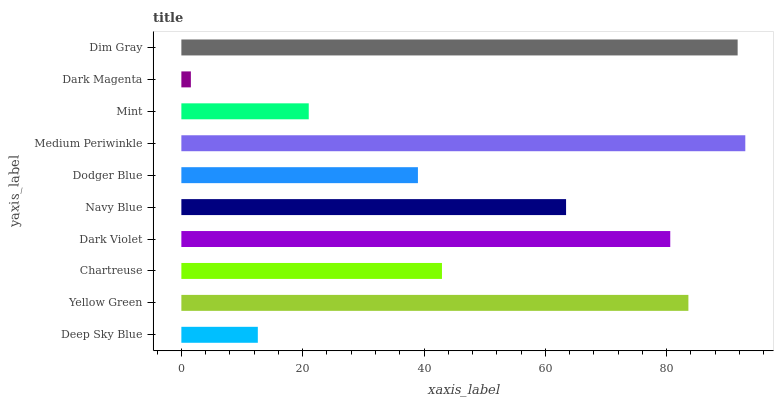Is Dark Magenta the minimum?
Answer yes or no. Yes. Is Medium Periwinkle the maximum?
Answer yes or no. Yes. Is Yellow Green the minimum?
Answer yes or no. No. Is Yellow Green the maximum?
Answer yes or no. No. Is Yellow Green greater than Deep Sky Blue?
Answer yes or no. Yes. Is Deep Sky Blue less than Yellow Green?
Answer yes or no. Yes. Is Deep Sky Blue greater than Yellow Green?
Answer yes or no. No. Is Yellow Green less than Deep Sky Blue?
Answer yes or no. No. Is Navy Blue the high median?
Answer yes or no. Yes. Is Chartreuse the low median?
Answer yes or no. Yes. Is Yellow Green the high median?
Answer yes or no. No. Is Dodger Blue the low median?
Answer yes or no. No. 